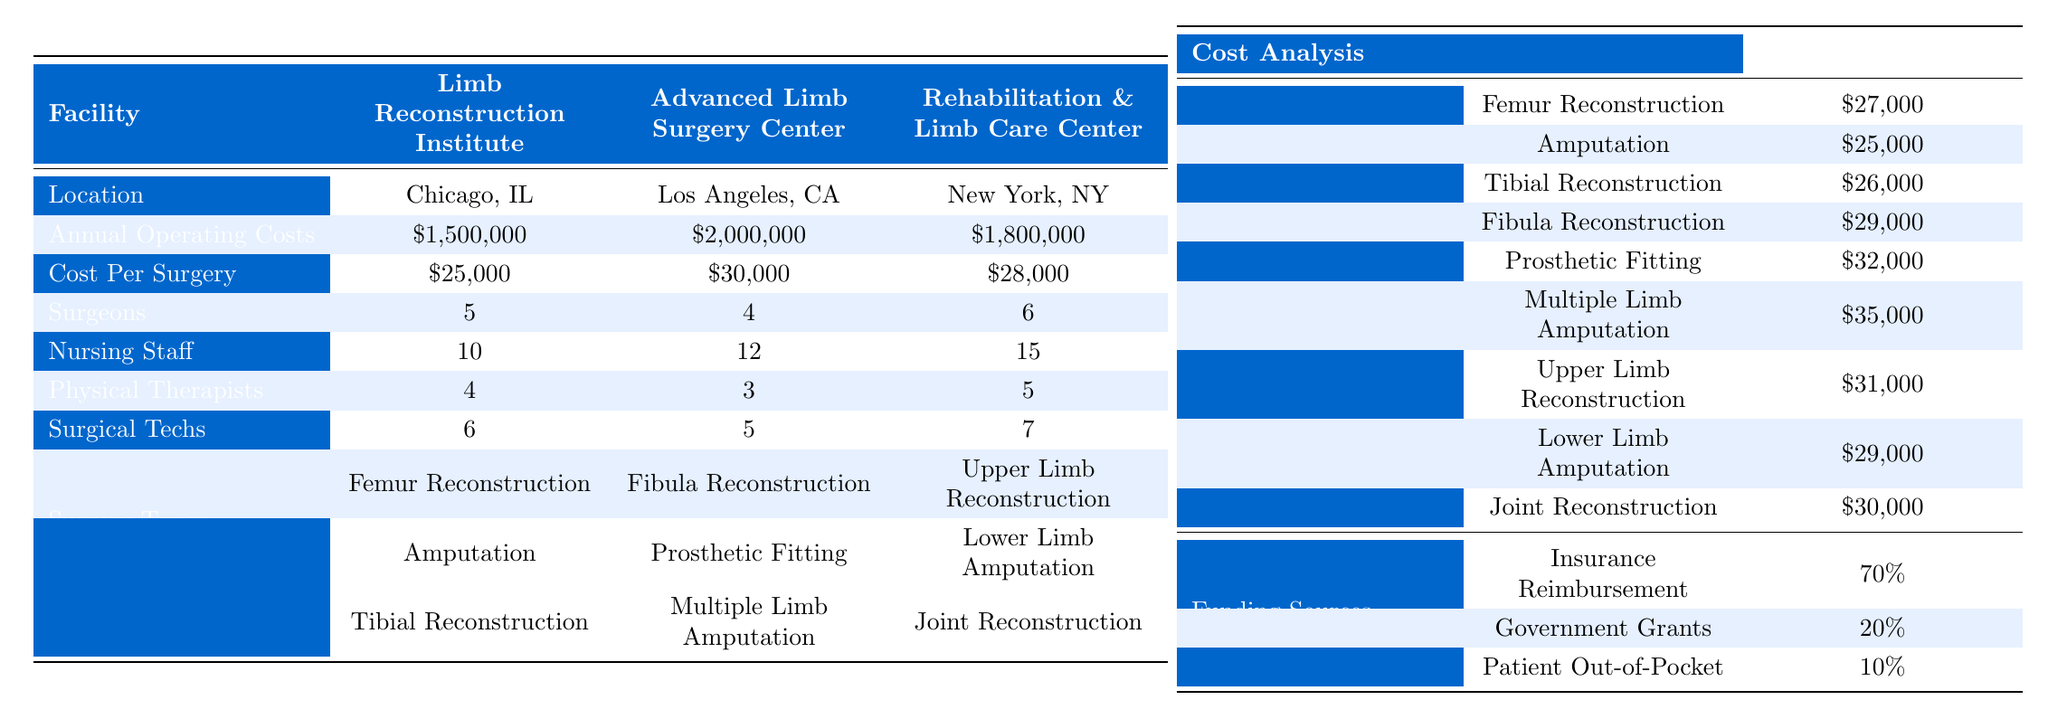What are the total annual operating costs for the Limb Reconstruction Institute? The table specifies that the annual operating costs for the Limb Reconstruction Institute are listed as $1,500,000.
Answer: $1,500,000 How many surgical techs are employed at the Rehabilitation & Limb Care Center? According to the table, the number of surgical techs at the Rehabilitation & Limb Care Center is counted as 7.
Answer: 7 What is the cost per surgery at the Advanced Limb Surgery Center? The cost per surgery for the Advanced Limb Surgery Center is stated in the table as $30,000.
Answer: $30,000 Which facility has the greatest number of nursing staff? The Rehabilitation & Limb Care Center has the highest count of nursing staff at 15, as seen in the table.
Answer: Rehabilitation & Limb Care Center What is the average cost of an Amputation surgery? The table shows that the average cost for an Amputation surgery is $25,000.
Answer: $25,000 How much more does it cost per surgery at the Advanced Limb Surgery Center compared to the Limb Reconstruction Institute? The Advanced Limb Surgery Center charges $30,000 per surgery, while the Limb Reconstruction Institute charges $25,000. The difference is calculated as $30,000 - $25,000 = $5,000.
Answer: $5,000 Is the cost of a Tibial Reconstruction higher than the average cost of a Femur Reconstruction? The average cost of Tibial Reconstruction is $26,000, while the average cost of Femur Reconstruction is $27,000. Since $26,000 is less than $27,000, the answer is no.
Answer: No What percentage of funding comes from patient out-of-pocket resources across all facilities? According to the table, patient out-of-pocket resources account for 10% of the funding sources. This is a specific reference point found directly in the Cost Analysis section.
Answer: 10% Which facility has the lowest operating costs, and by how much compared to the facility with the highest operating costs? The Limb Reconstruction Institute has the lowest annual operating costs at $1,500,000, while the Advanced Limb Surgery Center has the highest at $2,000,000. The difference is $2,000,000 - $1,500,000 = $500,000.
Answer: Limb Reconstruction Institute; $500,000 